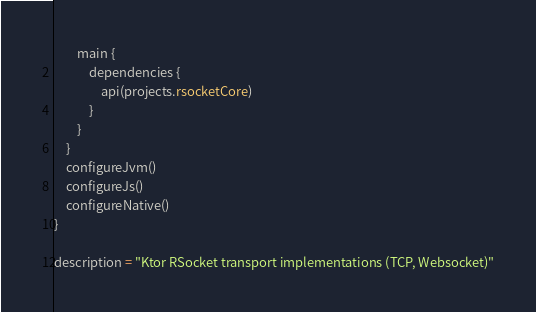Convert code to text. <code><loc_0><loc_0><loc_500><loc_500><_Kotlin_>        main {
            dependencies {
                api(projects.rsocketCore)
            }
        }
    }
    configureJvm()
    configureJs()
    configureNative()
}

description = "Ktor RSocket transport implementations (TCP, Websocket)"
</code> 